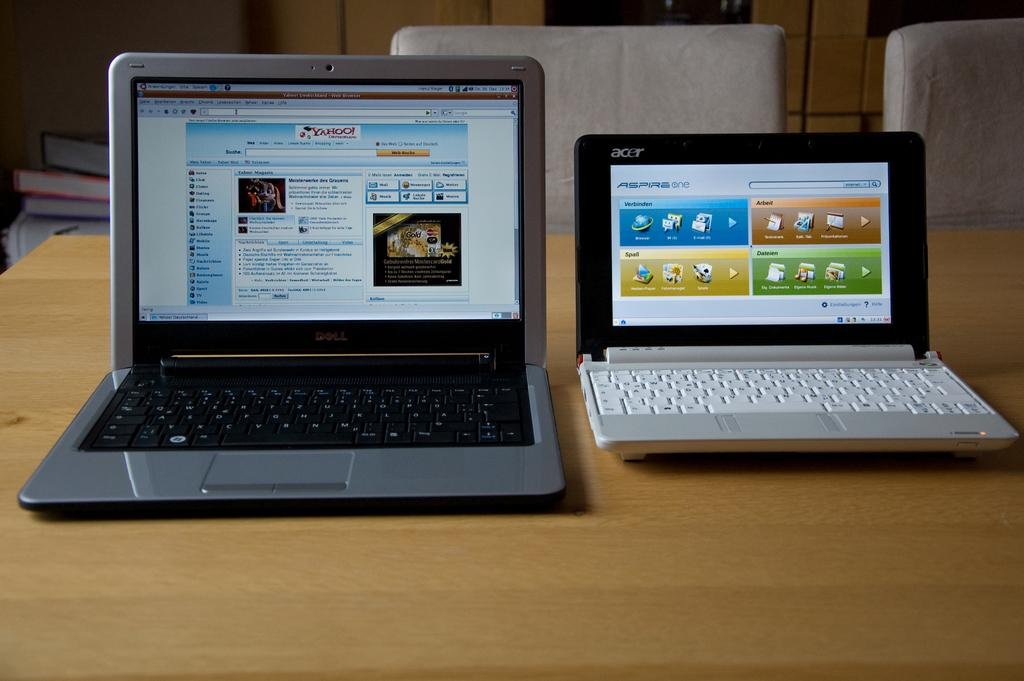What type of electronic devices are on the table in the image? There are laptops on a wooden table in the image. What can be seen behind the table in the image? There are chairs visible behind the table in the image. What type of plastic object is being jumped over by a woman in the image? There is no plastic object or woman present in the image. 